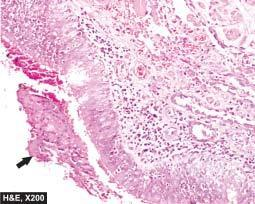what is sloughed off at places with exudate of muco-pus in the lumen?
Answer the question using a single word or phrase. Mucosa 